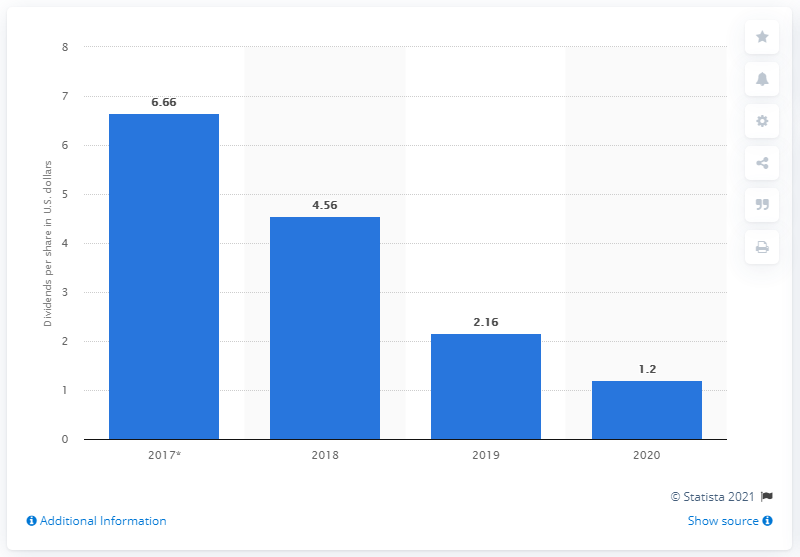Draw attention to some important aspects in this diagram. For how long has DuPont been over 4? From 2021 to 2022. The DuPont value reached its peak in 2017. 